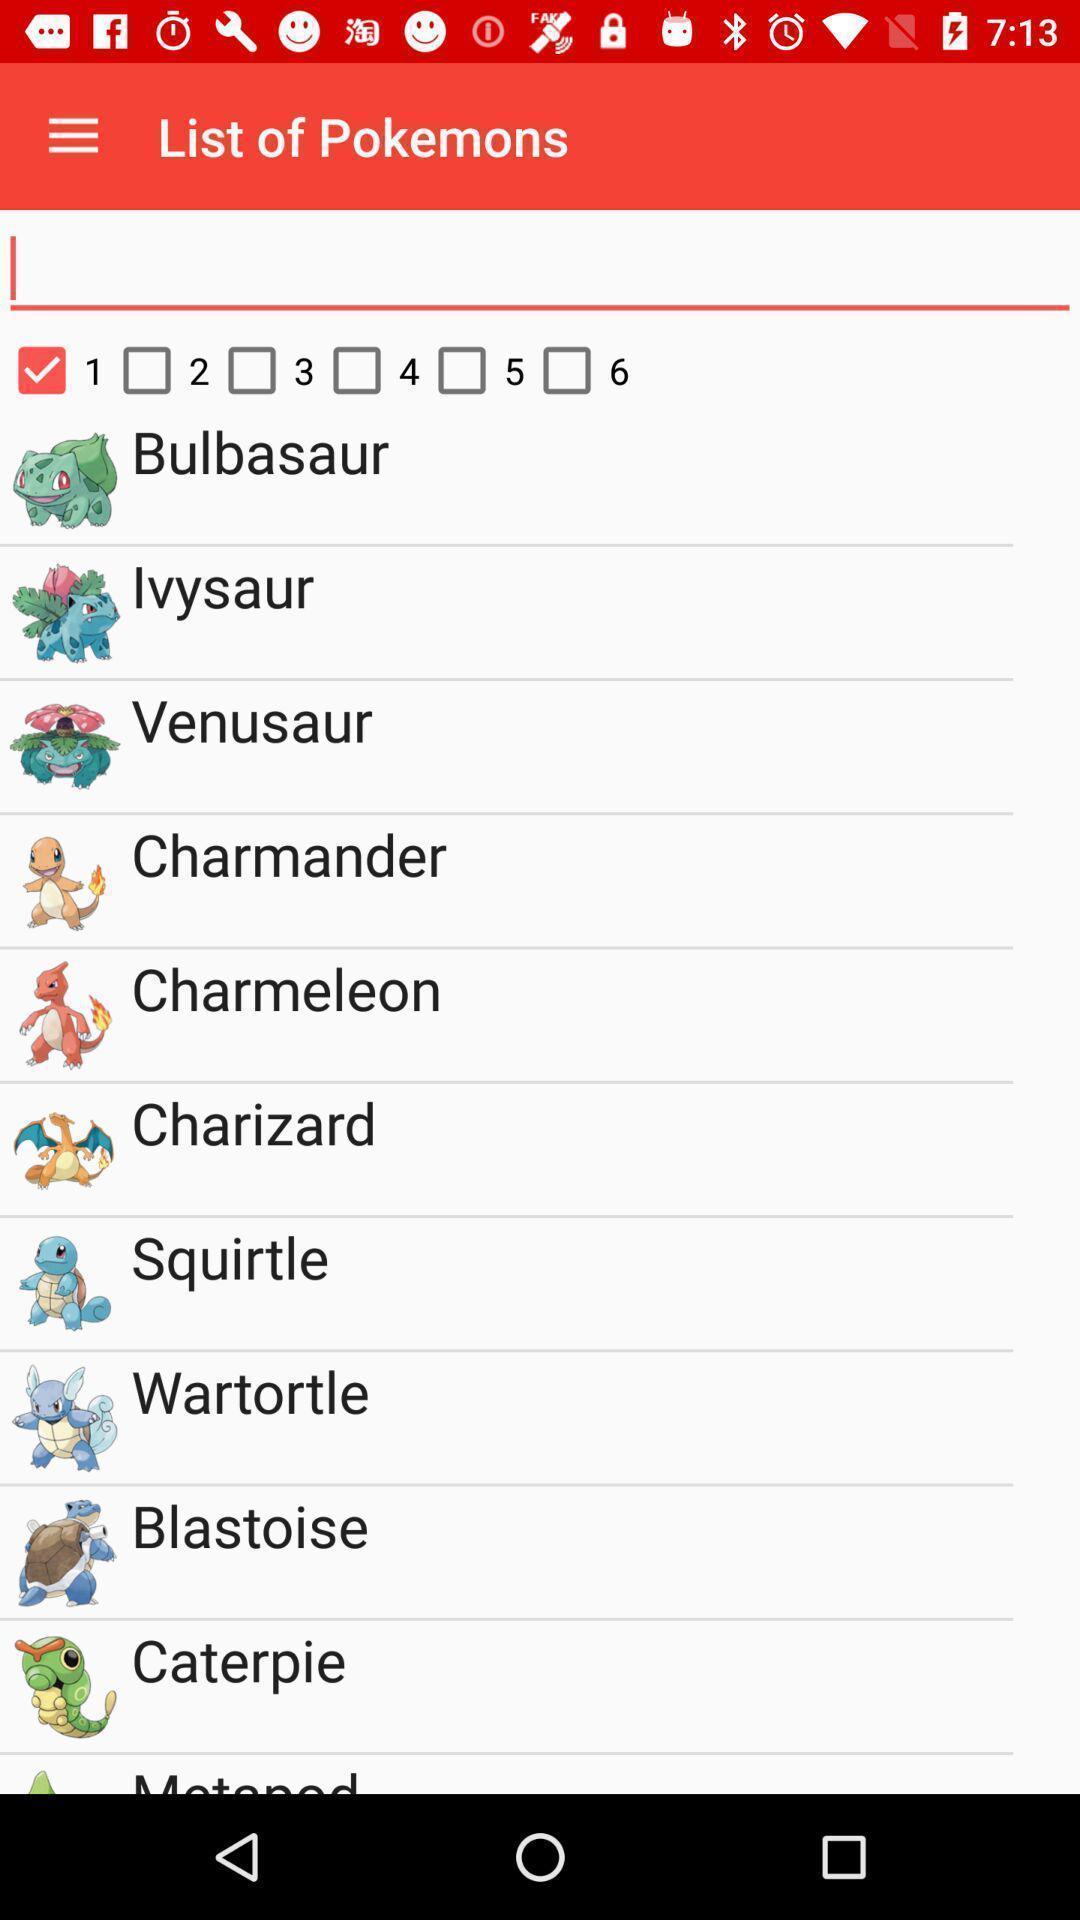Give me a summary of this screen capture. Page displaying list of cartoons. 